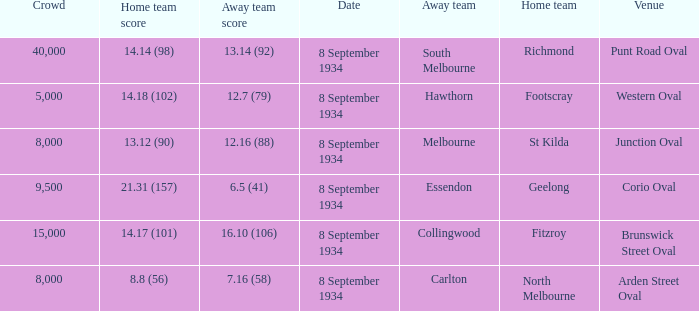When the Venue was Punt Road Oval, who was the Home Team? Richmond. 